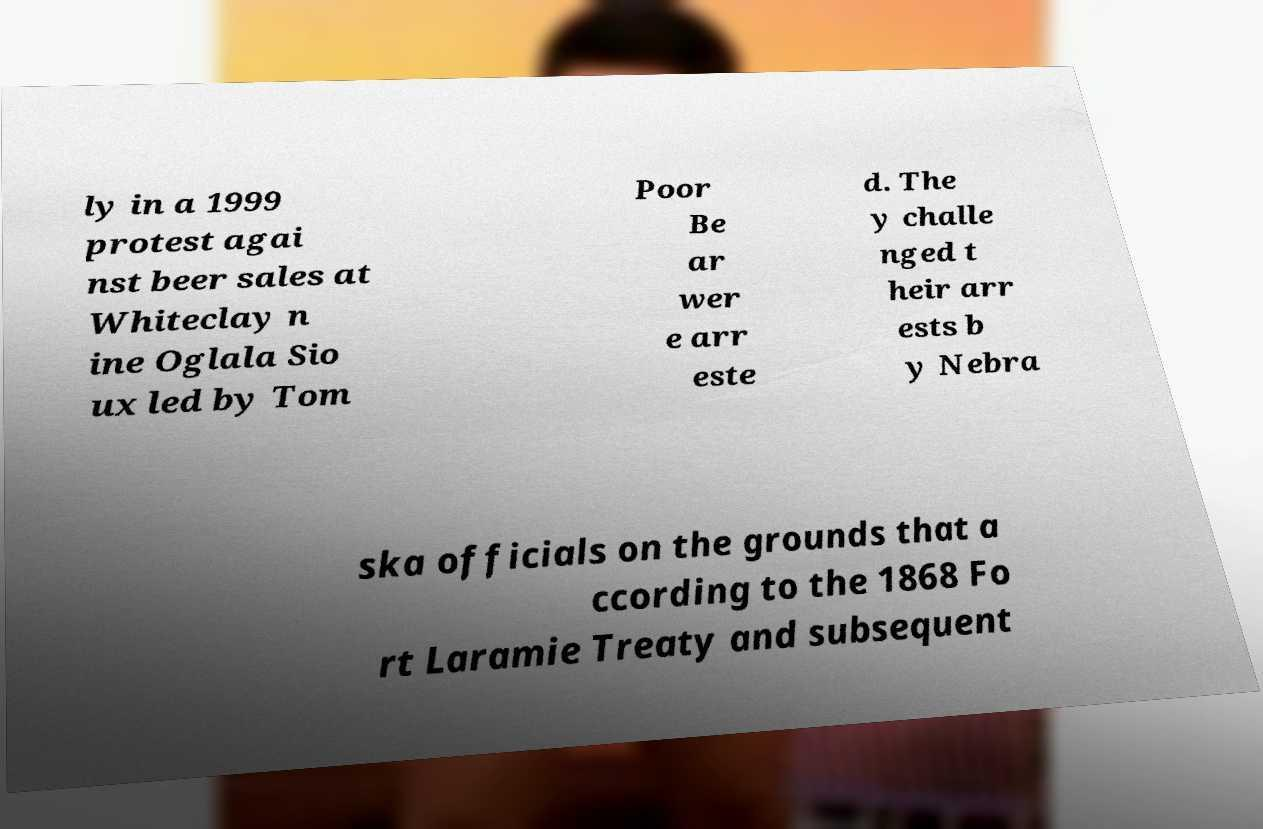Please read and relay the text visible in this image. What does it say? ly in a 1999 protest agai nst beer sales at Whiteclay n ine Oglala Sio ux led by Tom Poor Be ar wer e arr este d. The y challe nged t heir arr ests b y Nebra ska officials on the grounds that a ccording to the 1868 Fo rt Laramie Treaty and subsequent 